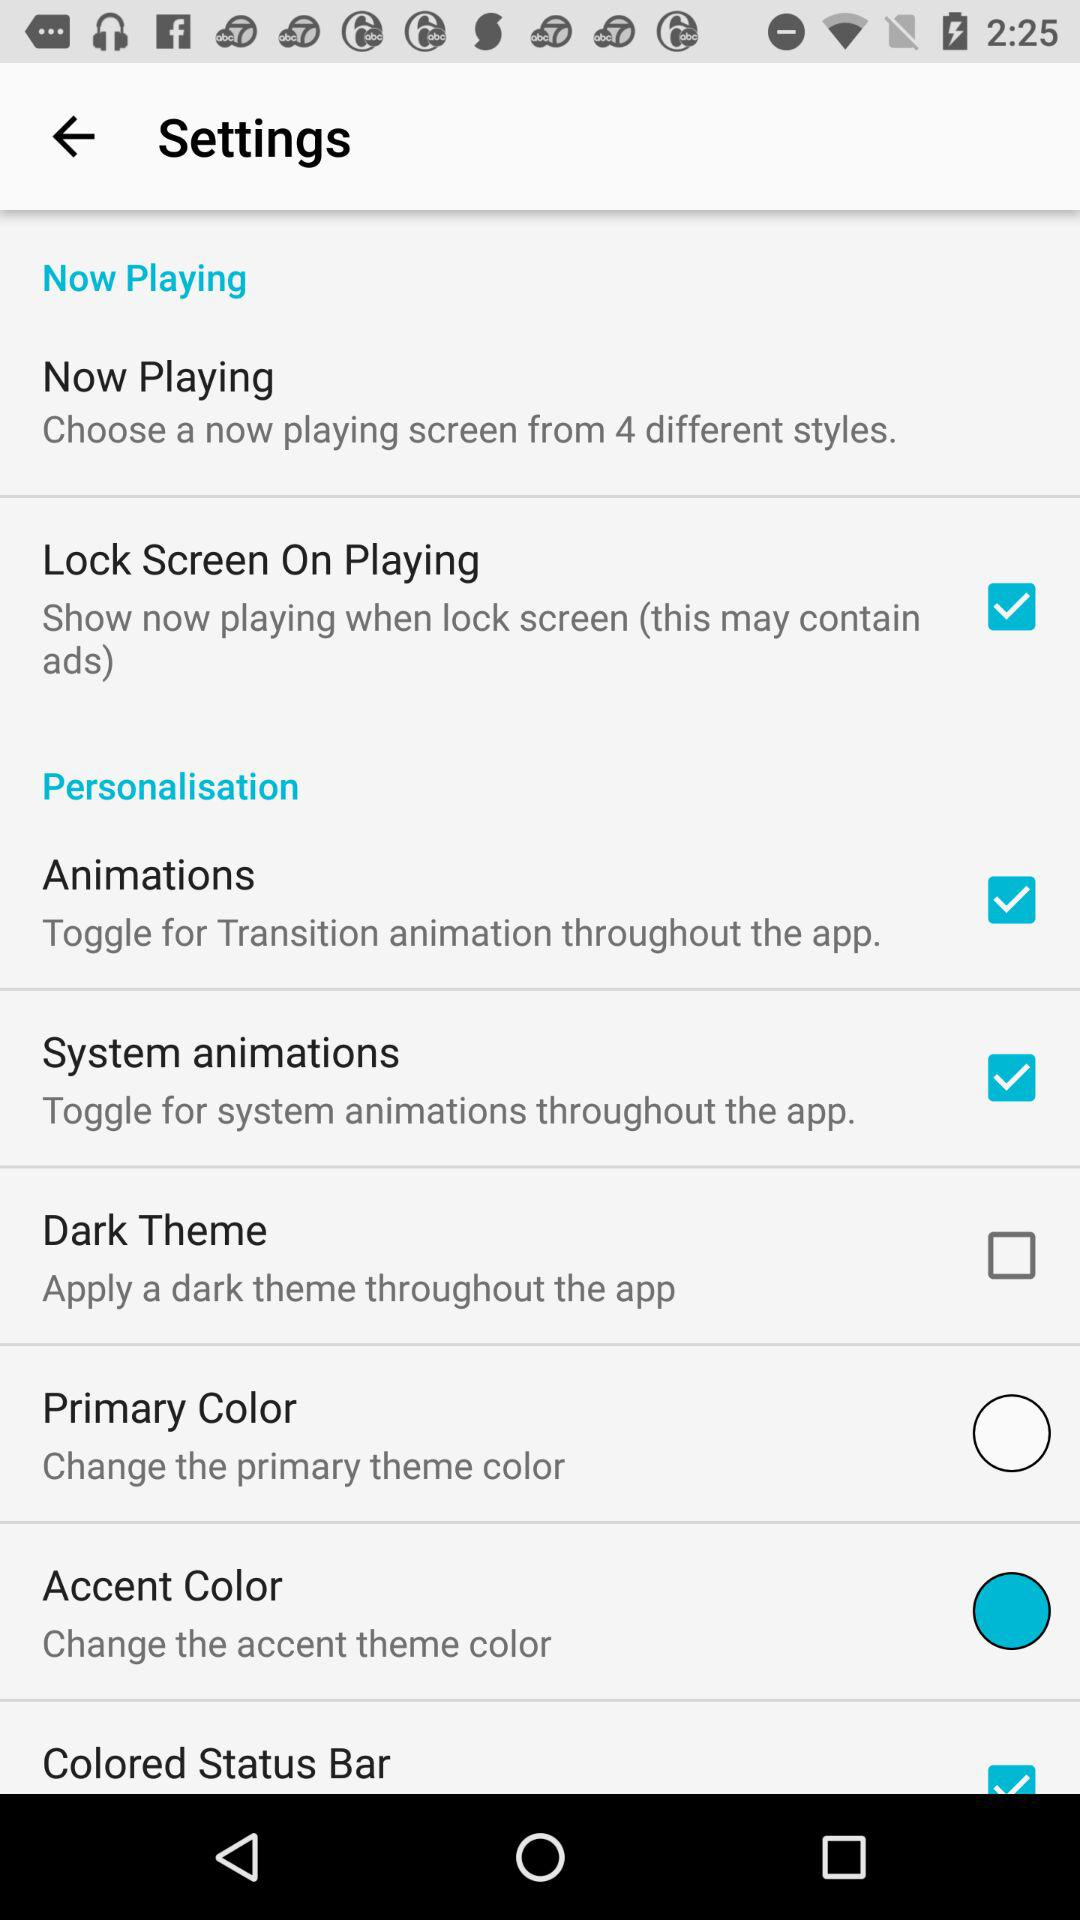What is the status of "Dark Theme"? The status of "Dark Theme" is "off". 